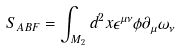<formula> <loc_0><loc_0><loc_500><loc_500>S _ { A B F } = \int _ { M _ { 2 } } d ^ { 2 } x \epsilon ^ { \mu \nu } \phi \partial _ { \mu } \omega _ { \nu }</formula> 